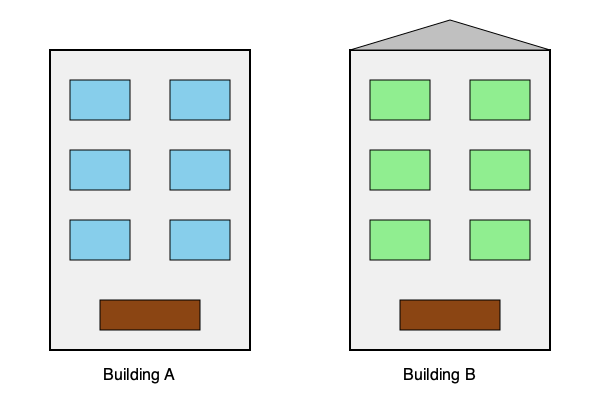As an artist inspired by sustainable architecture, which building facade demonstrates more energy-efficient design elements? To determine which building facade is more energy-efficient, we need to analyze the design elements of both buildings:

1. Building A:
   - Standard rectangular shape
   - Large, clear windows
   - Flat roof
   - No visible shading devices

2. Building B:
   - Sloped roof (possibly for better rainwater management or solar panel placement)
   - Slightly smaller windows with a green tint (suggesting energy-efficient glazing)
   - Overhanging roof eaves (providing natural shading)

Energy-efficient design elements in Building B:

a) Sloped roof: Can be used for better insulation, rainwater harvesting, or optimal placement of solar panels.
b) Green-tinted windows: Likely low-emissivity (low-E) glazing, which reduces heat transfer and improves insulation.
c) Overhanging roof: Provides natural shading, reducing solar heat gain in summer and lowering cooling costs.

These features contribute to better energy efficiency by:
- Reducing heating and cooling loads
- Improving natural lighting while minimizing heat gain
- Potentially incorporating renewable energy systems

Building A lacks these visible energy-efficient design elements, making it less sustainable in comparison.
Answer: Building B 